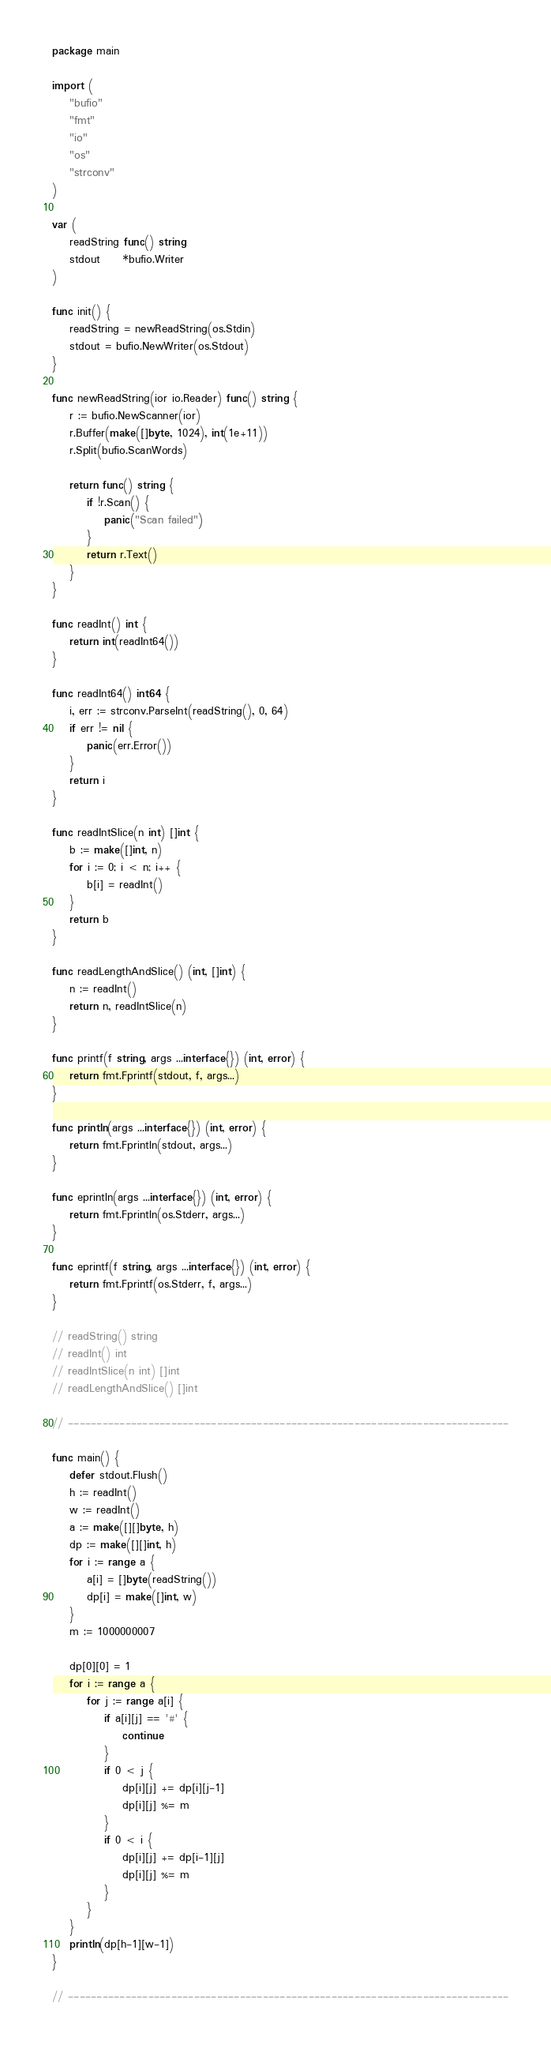Convert code to text. <code><loc_0><loc_0><loc_500><loc_500><_Go_>package main

import (
	"bufio"
	"fmt"
	"io"
	"os"
	"strconv"
)

var (
	readString func() string
	stdout     *bufio.Writer
)

func init() {
	readString = newReadString(os.Stdin)
	stdout = bufio.NewWriter(os.Stdout)
}

func newReadString(ior io.Reader) func() string {
	r := bufio.NewScanner(ior)
	r.Buffer(make([]byte, 1024), int(1e+11))
	r.Split(bufio.ScanWords)

	return func() string {
		if !r.Scan() {
			panic("Scan failed")
		}
		return r.Text()
	}
}

func readInt() int {
	return int(readInt64())
}

func readInt64() int64 {
	i, err := strconv.ParseInt(readString(), 0, 64)
	if err != nil {
		panic(err.Error())
	}
	return i
}

func readIntSlice(n int) []int {
	b := make([]int, n)
	for i := 0; i < n; i++ {
		b[i] = readInt()
	}
	return b
}

func readLengthAndSlice() (int, []int) {
	n := readInt()
	return n, readIntSlice(n)
}

func printf(f string, args ...interface{}) (int, error) {
	return fmt.Fprintf(stdout, f, args...)
}

func println(args ...interface{}) (int, error) {
	return fmt.Fprintln(stdout, args...)
}

func eprintln(args ...interface{}) (int, error) {
	return fmt.Fprintln(os.Stderr, args...)
}

func eprintf(f string, args ...interface{}) (int, error) {
	return fmt.Fprintf(os.Stderr, f, args...)
}

// readString() string
// readInt() int
// readIntSlice(n int) []int
// readLengthAndSlice() []int

// -----------------------------------------------------------------------------

func main() {
	defer stdout.Flush()
	h := readInt()
	w := readInt()
	a := make([][]byte, h)
	dp := make([][]int, h)
	for i := range a {
		a[i] = []byte(readString())
		dp[i] = make([]int, w)
	}
	m := 1000000007

	dp[0][0] = 1
	for i := range a {
		for j := range a[i] {
			if a[i][j] == '#' {
				continue
			}
			if 0 < j {
				dp[i][j] += dp[i][j-1]
				dp[i][j] %= m
			}
			if 0 < i {
				dp[i][j] += dp[i-1][j]
				dp[i][j] %= m
			}
		}
	}
	println(dp[h-1][w-1])
}

// -----------------------------------------------------------------------------
</code> 